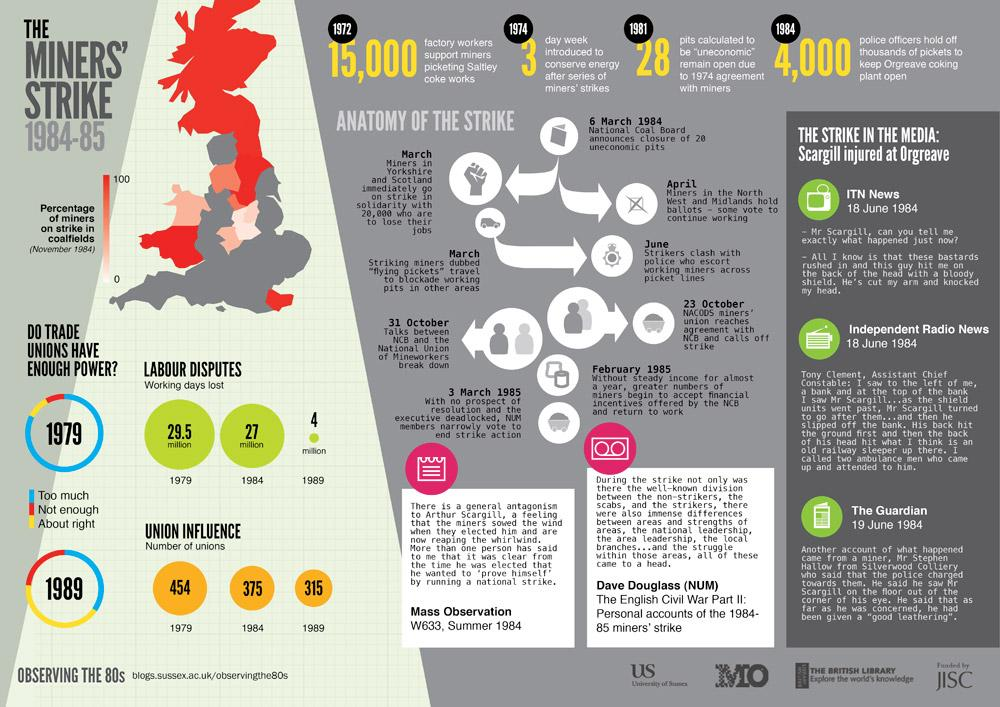Identify some key points in this picture. In 1974, in response to a series of miners' strikes and the need to conserve energy, a three-day work week was introduced. There were 454 trade unions involved in the Miners' Strike of 1979. In the year 1989, there were 315 trade unions participating in the Miners' Strike. In 1984, a total of 27 million working days were lost due to labor disputes. In 1989, an estimated 4 million working days were lost due to labour disputes. 